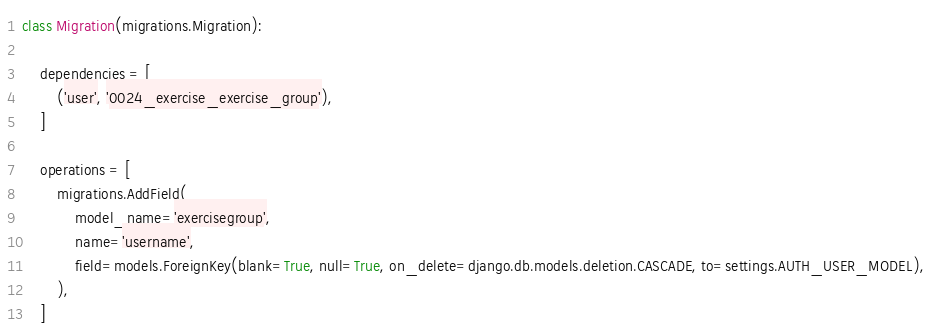<code> <loc_0><loc_0><loc_500><loc_500><_Python_>
class Migration(migrations.Migration):

    dependencies = [
        ('user', '0024_exercise_exercise_group'),
    ]

    operations = [
        migrations.AddField(
            model_name='exercisegroup',
            name='username',
            field=models.ForeignKey(blank=True, null=True, on_delete=django.db.models.deletion.CASCADE, to=settings.AUTH_USER_MODEL),
        ),
    ]
</code> 